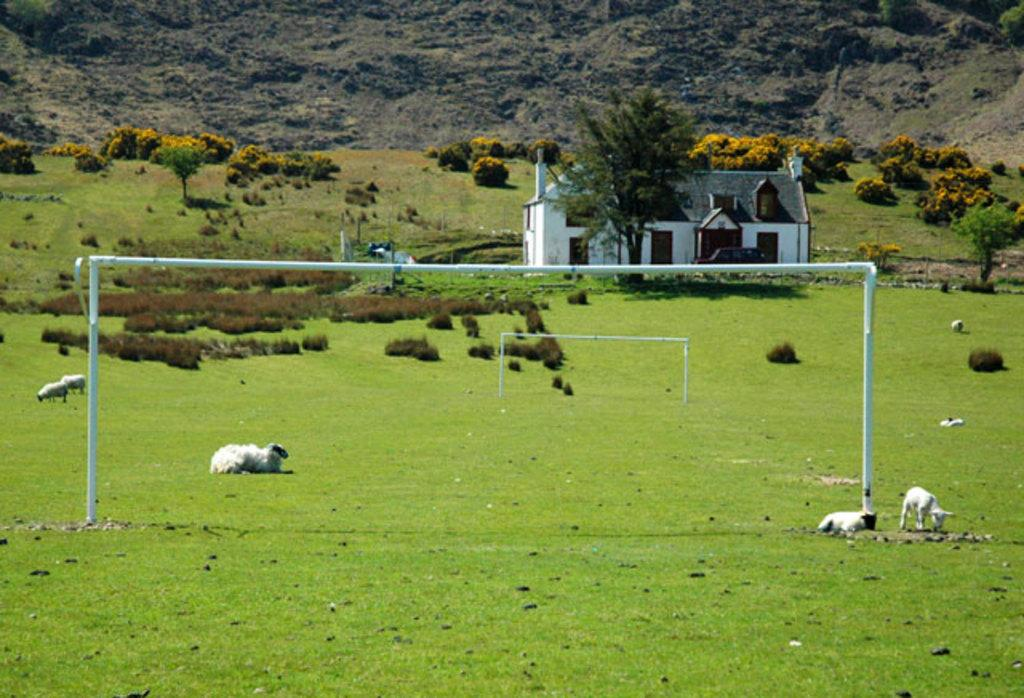What types of living organisms can be seen in the image? There are animals in the image. What material is present in the image that is typically used for construction? There are iron rods in the image, which are commonly used for construction. What type of vegetation is visible in the image? There is grass, plants, and trees in the image. What type of structure is present in the image? There is a house in the image. What color is the stocking hanging on the tree in the image? There is no stocking present in the image; it only features animals, iron rods, grass, plants, a house, and trees. What type of glass object can be seen on the table in the image? There is no glass object present in the image. 